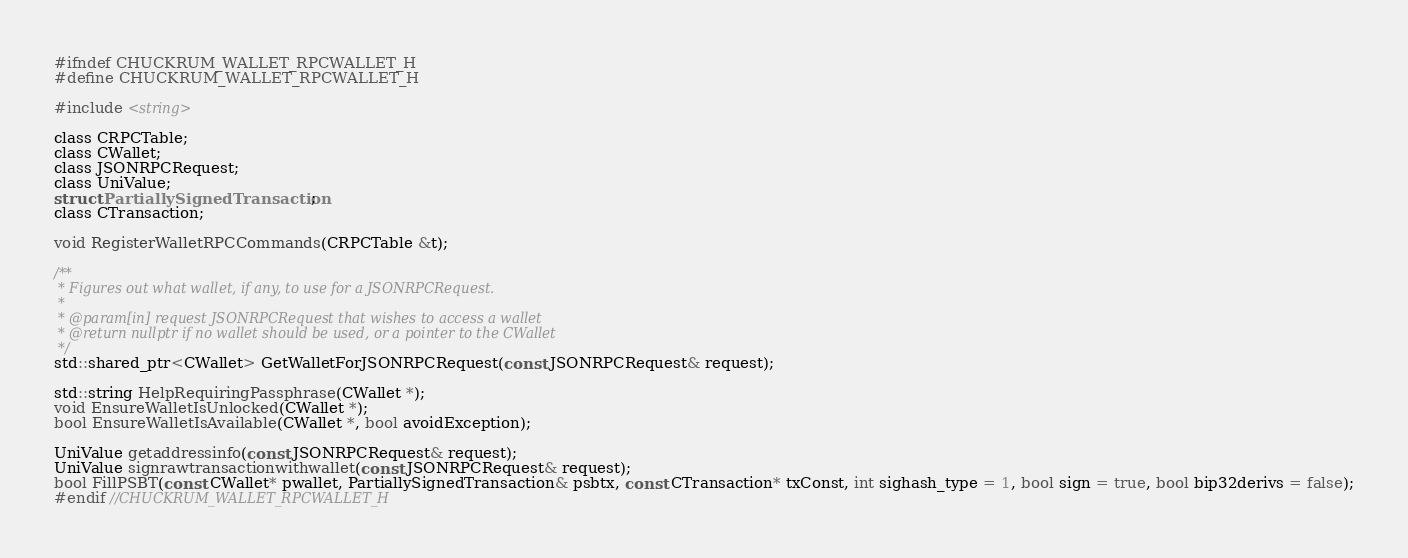Convert code to text. <code><loc_0><loc_0><loc_500><loc_500><_C_>
#ifndef CHUCKRUM_WALLET_RPCWALLET_H
#define CHUCKRUM_WALLET_RPCWALLET_H

#include <string>

class CRPCTable;
class CWallet;
class JSONRPCRequest;
class UniValue;
struct PartiallySignedTransaction;
class CTransaction;

void RegisterWalletRPCCommands(CRPCTable &t);

/**
 * Figures out what wallet, if any, to use for a JSONRPCRequest.
 *
 * @param[in] request JSONRPCRequest that wishes to access a wallet
 * @return nullptr if no wallet should be used, or a pointer to the CWallet
 */
std::shared_ptr<CWallet> GetWalletForJSONRPCRequest(const JSONRPCRequest& request);

std::string HelpRequiringPassphrase(CWallet *);
void EnsureWalletIsUnlocked(CWallet *);
bool EnsureWalletIsAvailable(CWallet *, bool avoidException);

UniValue getaddressinfo(const JSONRPCRequest& request);
UniValue signrawtransactionwithwallet(const JSONRPCRequest& request);
bool FillPSBT(const CWallet* pwallet, PartiallySignedTransaction& psbtx, const CTransaction* txConst, int sighash_type = 1, bool sign = true, bool bip32derivs = false);
#endif //CHUCKRUM_WALLET_RPCWALLET_H
</code> 